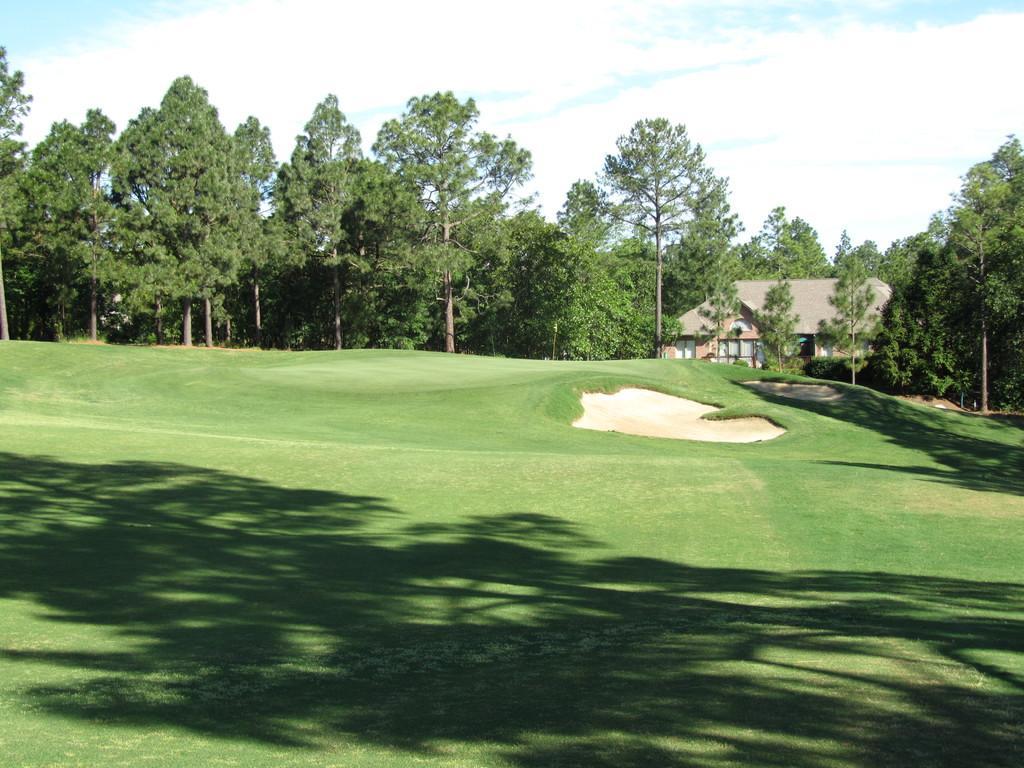Please provide a concise description of this image. In this image we can see sky with clouds, trees, building and ground. 